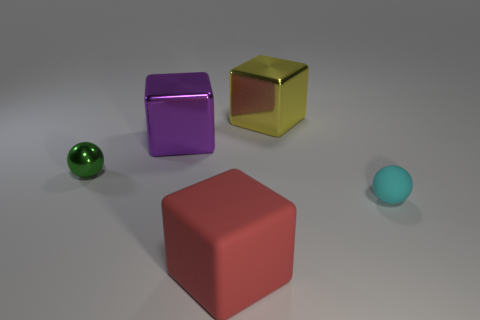Subtract all red matte blocks. How many blocks are left? 2 Add 4 tiny cylinders. How many objects exist? 9 Subtract all green balls. How many balls are left? 1 Subtract all blocks. How many objects are left? 2 Subtract 1 spheres. How many spheres are left? 1 Subtract all gray balls. Subtract all red cylinders. How many balls are left? 2 Subtract all purple metallic blocks. Subtract all small balls. How many objects are left? 2 Add 3 green metal balls. How many green metal balls are left? 4 Add 1 purple metal balls. How many purple metal balls exist? 1 Subtract 0 brown spheres. How many objects are left? 5 